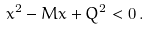<formula> <loc_0><loc_0><loc_500><loc_500>x ^ { 2 } - M x + Q ^ { 2 } < 0 \, .</formula> 